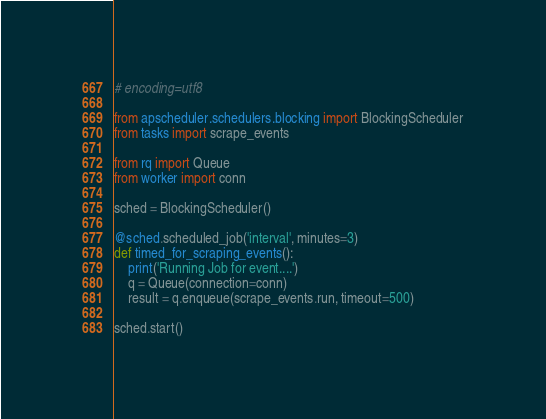Convert code to text. <code><loc_0><loc_0><loc_500><loc_500><_Python_># encoding=utf8

from apscheduler.schedulers.blocking import BlockingScheduler
from tasks import scrape_events

from rq import Queue
from worker import conn

sched = BlockingScheduler()

@sched.scheduled_job('interval', minutes=3)
def timed_for_scraping_events():
    print('Running Job for event....')
    q = Queue(connection=conn)
    result = q.enqueue(scrape_events.run, timeout=500)
    
sched.start()
</code> 